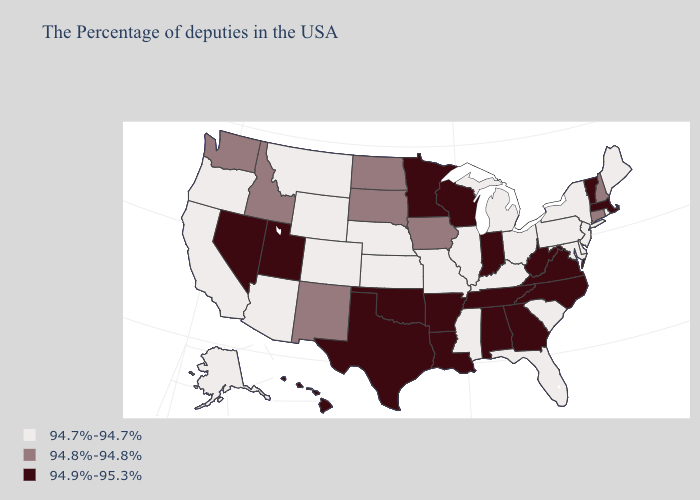Name the states that have a value in the range 94.7%-94.7%?
Concise answer only. Maine, Rhode Island, New York, New Jersey, Delaware, Maryland, Pennsylvania, South Carolina, Ohio, Florida, Michigan, Kentucky, Illinois, Mississippi, Missouri, Kansas, Nebraska, Wyoming, Colorado, Montana, Arizona, California, Oregon, Alaska. Name the states that have a value in the range 94.8%-94.8%?
Short answer required. New Hampshire, Connecticut, Iowa, South Dakota, North Dakota, New Mexico, Idaho, Washington. Name the states that have a value in the range 94.9%-95.3%?
Keep it brief. Massachusetts, Vermont, Virginia, North Carolina, West Virginia, Georgia, Indiana, Alabama, Tennessee, Wisconsin, Louisiana, Arkansas, Minnesota, Oklahoma, Texas, Utah, Nevada, Hawaii. What is the value of Virginia?
Answer briefly. 94.9%-95.3%. Does the first symbol in the legend represent the smallest category?
Short answer required. Yes. Name the states that have a value in the range 94.7%-94.7%?
Concise answer only. Maine, Rhode Island, New York, New Jersey, Delaware, Maryland, Pennsylvania, South Carolina, Ohio, Florida, Michigan, Kentucky, Illinois, Mississippi, Missouri, Kansas, Nebraska, Wyoming, Colorado, Montana, Arizona, California, Oregon, Alaska. Which states have the highest value in the USA?
Keep it brief. Massachusetts, Vermont, Virginia, North Carolina, West Virginia, Georgia, Indiana, Alabama, Tennessee, Wisconsin, Louisiana, Arkansas, Minnesota, Oklahoma, Texas, Utah, Nevada, Hawaii. What is the value of Ohio?
Short answer required. 94.7%-94.7%. Name the states that have a value in the range 94.7%-94.7%?
Short answer required. Maine, Rhode Island, New York, New Jersey, Delaware, Maryland, Pennsylvania, South Carolina, Ohio, Florida, Michigan, Kentucky, Illinois, Mississippi, Missouri, Kansas, Nebraska, Wyoming, Colorado, Montana, Arizona, California, Oregon, Alaska. Does the first symbol in the legend represent the smallest category?
Keep it brief. Yes. What is the value of Oklahoma?
Short answer required. 94.9%-95.3%. Name the states that have a value in the range 94.7%-94.7%?
Answer briefly. Maine, Rhode Island, New York, New Jersey, Delaware, Maryland, Pennsylvania, South Carolina, Ohio, Florida, Michigan, Kentucky, Illinois, Mississippi, Missouri, Kansas, Nebraska, Wyoming, Colorado, Montana, Arizona, California, Oregon, Alaska. Does New York have the highest value in the USA?
Be succinct. No. Name the states that have a value in the range 94.8%-94.8%?
Keep it brief. New Hampshire, Connecticut, Iowa, South Dakota, North Dakota, New Mexico, Idaho, Washington. 